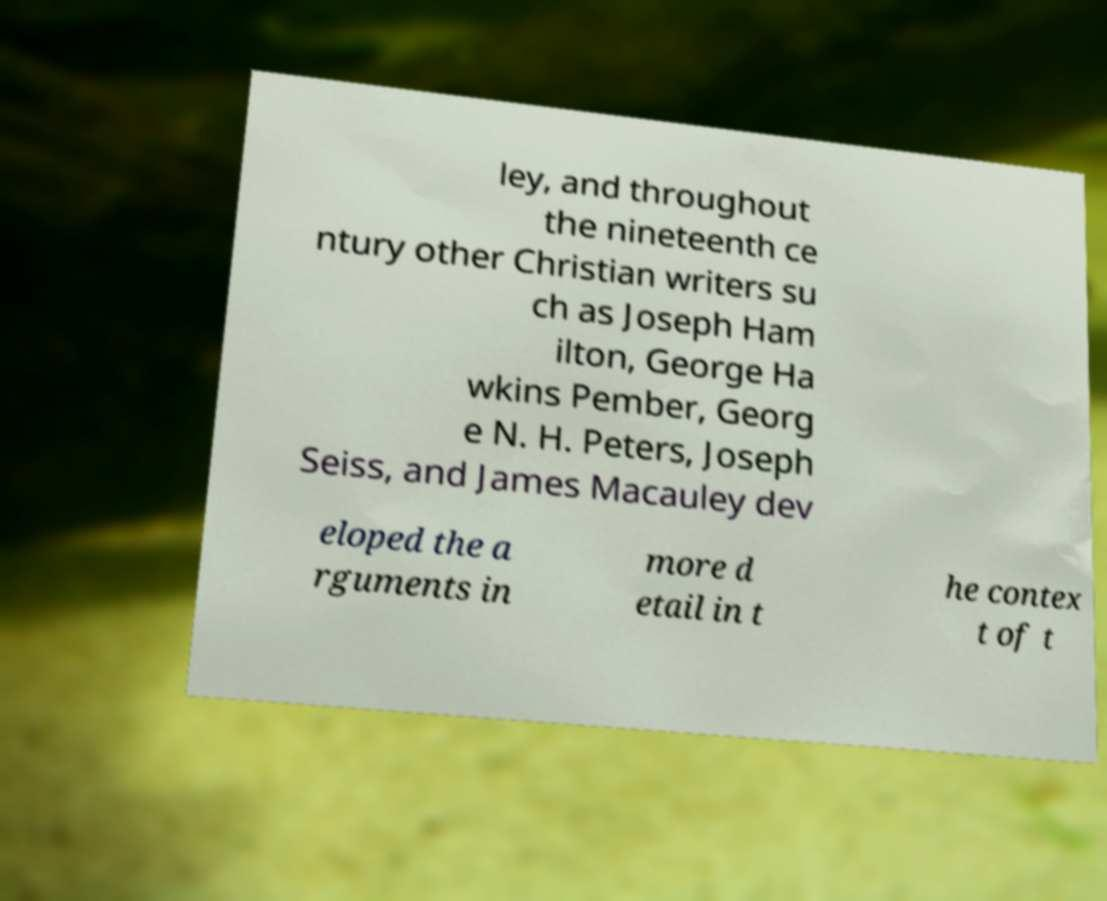Please identify and transcribe the text found in this image. ley, and throughout the nineteenth ce ntury other Christian writers su ch as Joseph Ham ilton, George Ha wkins Pember, Georg e N. H. Peters, Joseph Seiss, and James Macauley dev eloped the a rguments in more d etail in t he contex t of t 